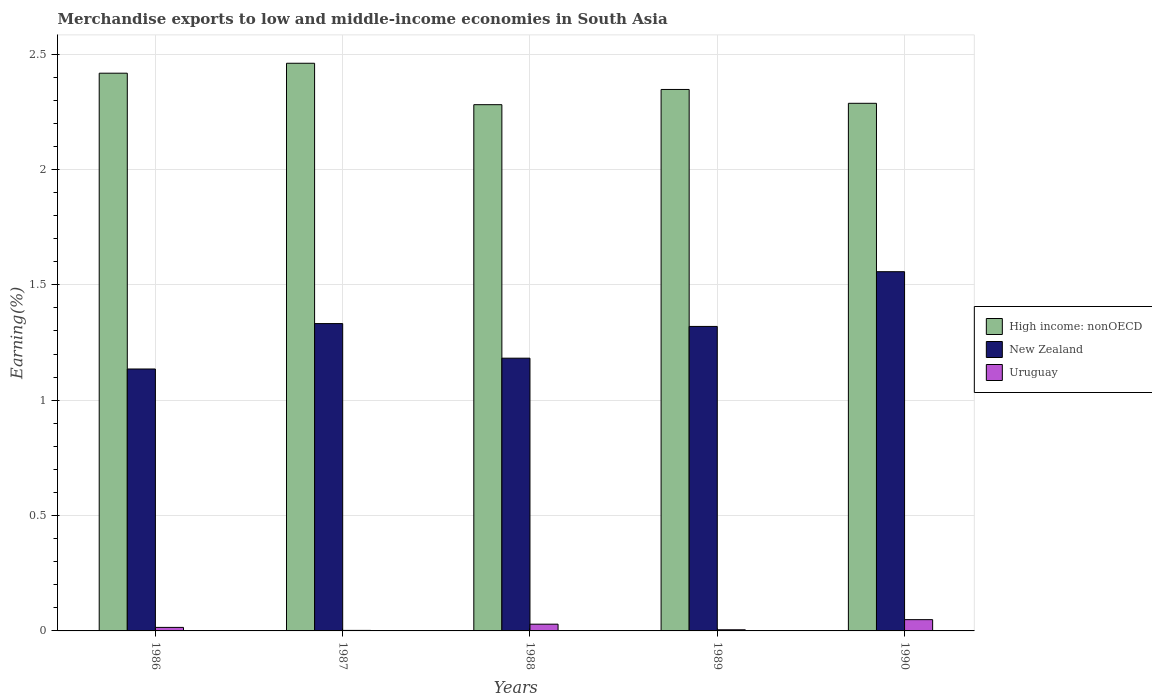How many different coloured bars are there?
Ensure brevity in your answer.  3. How many groups of bars are there?
Your answer should be compact. 5. How many bars are there on the 1st tick from the right?
Give a very brief answer. 3. In how many cases, is the number of bars for a given year not equal to the number of legend labels?
Ensure brevity in your answer.  0. What is the percentage of amount earned from merchandise exports in High income: nonOECD in 1987?
Your answer should be compact. 2.46. Across all years, what is the maximum percentage of amount earned from merchandise exports in Uruguay?
Ensure brevity in your answer.  0.05. Across all years, what is the minimum percentage of amount earned from merchandise exports in High income: nonOECD?
Provide a succinct answer. 2.28. In which year was the percentage of amount earned from merchandise exports in Uruguay maximum?
Offer a very short reply. 1990. What is the total percentage of amount earned from merchandise exports in Uruguay in the graph?
Give a very brief answer. 0.1. What is the difference between the percentage of amount earned from merchandise exports in New Zealand in 1987 and that in 1989?
Offer a very short reply. 0.01. What is the difference between the percentage of amount earned from merchandise exports in Uruguay in 1986 and the percentage of amount earned from merchandise exports in New Zealand in 1990?
Make the answer very short. -1.54. What is the average percentage of amount earned from merchandise exports in High income: nonOECD per year?
Keep it short and to the point. 2.36. In the year 1987, what is the difference between the percentage of amount earned from merchandise exports in New Zealand and percentage of amount earned from merchandise exports in High income: nonOECD?
Your response must be concise. -1.13. In how many years, is the percentage of amount earned from merchandise exports in Uruguay greater than 1.7 %?
Your answer should be compact. 0. What is the ratio of the percentage of amount earned from merchandise exports in New Zealand in 1989 to that in 1990?
Provide a succinct answer. 0.85. Is the percentage of amount earned from merchandise exports in Uruguay in 1986 less than that in 1988?
Your response must be concise. Yes. What is the difference between the highest and the second highest percentage of amount earned from merchandise exports in New Zealand?
Your answer should be compact. 0.22. What is the difference between the highest and the lowest percentage of amount earned from merchandise exports in Uruguay?
Ensure brevity in your answer.  0.05. What does the 1st bar from the left in 1987 represents?
Offer a terse response. High income: nonOECD. What does the 2nd bar from the right in 1988 represents?
Keep it short and to the point. New Zealand. Is it the case that in every year, the sum of the percentage of amount earned from merchandise exports in High income: nonOECD and percentage of amount earned from merchandise exports in New Zealand is greater than the percentage of amount earned from merchandise exports in Uruguay?
Offer a very short reply. Yes. Are all the bars in the graph horizontal?
Give a very brief answer. No. Where does the legend appear in the graph?
Provide a short and direct response. Center right. What is the title of the graph?
Your answer should be very brief. Merchandise exports to low and middle-income economies in South Asia. Does "Northern Mariana Islands" appear as one of the legend labels in the graph?
Make the answer very short. No. What is the label or title of the X-axis?
Offer a terse response. Years. What is the label or title of the Y-axis?
Offer a terse response. Earning(%). What is the Earning(%) in High income: nonOECD in 1986?
Your response must be concise. 2.42. What is the Earning(%) of New Zealand in 1986?
Ensure brevity in your answer.  1.14. What is the Earning(%) of Uruguay in 1986?
Provide a short and direct response. 0.02. What is the Earning(%) in High income: nonOECD in 1987?
Keep it short and to the point. 2.46. What is the Earning(%) in New Zealand in 1987?
Keep it short and to the point. 1.33. What is the Earning(%) in Uruguay in 1987?
Offer a very short reply. 0. What is the Earning(%) of High income: nonOECD in 1988?
Make the answer very short. 2.28. What is the Earning(%) of New Zealand in 1988?
Your answer should be compact. 1.18. What is the Earning(%) of Uruguay in 1988?
Make the answer very short. 0.03. What is the Earning(%) of High income: nonOECD in 1989?
Offer a very short reply. 2.35. What is the Earning(%) in New Zealand in 1989?
Offer a terse response. 1.32. What is the Earning(%) in Uruguay in 1989?
Keep it short and to the point. 0. What is the Earning(%) in High income: nonOECD in 1990?
Offer a terse response. 2.29. What is the Earning(%) in New Zealand in 1990?
Make the answer very short. 1.56. What is the Earning(%) in Uruguay in 1990?
Keep it short and to the point. 0.05. Across all years, what is the maximum Earning(%) in High income: nonOECD?
Your answer should be compact. 2.46. Across all years, what is the maximum Earning(%) of New Zealand?
Offer a very short reply. 1.56. Across all years, what is the maximum Earning(%) in Uruguay?
Your response must be concise. 0.05. Across all years, what is the minimum Earning(%) of High income: nonOECD?
Your response must be concise. 2.28. Across all years, what is the minimum Earning(%) of New Zealand?
Keep it short and to the point. 1.14. Across all years, what is the minimum Earning(%) of Uruguay?
Make the answer very short. 0. What is the total Earning(%) of High income: nonOECD in the graph?
Provide a succinct answer. 11.79. What is the total Earning(%) in New Zealand in the graph?
Offer a terse response. 6.53. What is the total Earning(%) of Uruguay in the graph?
Ensure brevity in your answer.  0.1. What is the difference between the Earning(%) of High income: nonOECD in 1986 and that in 1987?
Offer a terse response. -0.04. What is the difference between the Earning(%) in New Zealand in 1986 and that in 1987?
Provide a short and direct response. -0.2. What is the difference between the Earning(%) in Uruguay in 1986 and that in 1987?
Your answer should be compact. 0.01. What is the difference between the Earning(%) in High income: nonOECD in 1986 and that in 1988?
Your answer should be compact. 0.14. What is the difference between the Earning(%) of New Zealand in 1986 and that in 1988?
Offer a terse response. -0.05. What is the difference between the Earning(%) in Uruguay in 1986 and that in 1988?
Your response must be concise. -0.01. What is the difference between the Earning(%) in High income: nonOECD in 1986 and that in 1989?
Your answer should be compact. 0.07. What is the difference between the Earning(%) of New Zealand in 1986 and that in 1989?
Ensure brevity in your answer.  -0.18. What is the difference between the Earning(%) in Uruguay in 1986 and that in 1989?
Provide a succinct answer. 0.01. What is the difference between the Earning(%) of High income: nonOECD in 1986 and that in 1990?
Keep it short and to the point. 0.13. What is the difference between the Earning(%) of New Zealand in 1986 and that in 1990?
Your response must be concise. -0.42. What is the difference between the Earning(%) in Uruguay in 1986 and that in 1990?
Offer a very short reply. -0.03. What is the difference between the Earning(%) of High income: nonOECD in 1987 and that in 1988?
Your answer should be compact. 0.18. What is the difference between the Earning(%) in New Zealand in 1987 and that in 1988?
Your answer should be very brief. 0.15. What is the difference between the Earning(%) in Uruguay in 1987 and that in 1988?
Offer a very short reply. -0.03. What is the difference between the Earning(%) in High income: nonOECD in 1987 and that in 1989?
Your answer should be compact. 0.11. What is the difference between the Earning(%) in New Zealand in 1987 and that in 1989?
Make the answer very short. 0.01. What is the difference between the Earning(%) of Uruguay in 1987 and that in 1989?
Offer a very short reply. -0. What is the difference between the Earning(%) in High income: nonOECD in 1987 and that in 1990?
Ensure brevity in your answer.  0.17. What is the difference between the Earning(%) of New Zealand in 1987 and that in 1990?
Offer a very short reply. -0.22. What is the difference between the Earning(%) of Uruguay in 1987 and that in 1990?
Ensure brevity in your answer.  -0.05. What is the difference between the Earning(%) in High income: nonOECD in 1988 and that in 1989?
Offer a terse response. -0.07. What is the difference between the Earning(%) of New Zealand in 1988 and that in 1989?
Keep it short and to the point. -0.14. What is the difference between the Earning(%) in Uruguay in 1988 and that in 1989?
Your response must be concise. 0.02. What is the difference between the Earning(%) in High income: nonOECD in 1988 and that in 1990?
Ensure brevity in your answer.  -0.01. What is the difference between the Earning(%) of New Zealand in 1988 and that in 1990?
Your answer should be compact. -0.37. What is the difference between the Earning(%) in Uruguay in 1988 and that in 1990?
Your response must be concise. -0.02. What is the difference between the Earning(%) in New Zealand in 1989 and that in 1990?
Make the answer very short. -0.24. What is the difference between the Earning(%) in Uruguay in 1989 and that in 1990?
Your answer should be compact. -0.04. What is the difference between the Earning(%) of High income: nonOECD in 1986 and the Earning(%) of New Zealand in 1987?
Ensure brevity in your answer.  1.09. What is the difference between the Earning(%) of High income: nonOECD in 1986 and the Earning(%) of Uruguay in 1987?
Give a very brief answer. 2.42. What is the difference between the Earning(%) in New Zealand in 1986 and the Earning(%) in Uruguay in 1987?
Your answer should be compact. 1.13. What is the difference between the Earning(%) of High income: nonOECD in 1986 and the Earning(%) of New Zealand in 1988?
Provide a succinct answer. 1.24. What is the difference between the Earning(%) of High income: nonOECD in 1986 and the Earning(%) of Uruguay in 1988?
Ensure brevity in your answer.  2.39. What is the difference between the Earning(%) of New Zealand in 1986 and the Earning(%) of Uruguay in 1988?
Offer a very short reply. 1.11. What is the difference between the Earning(%) of High income: nonOECD in 1986 and the Earning(%) of New Zealand in 1989?
Keep it short and to the point. 1.1. What is the difference between the Earning(%) in High income: nonOECD in 1986 and the Earning(%) in Uruguay in 1989?
Offer a very short reply. 2.41. What is the difference between the Earning(%) of New Zealand in 1986 and the Earning(%) of Uruguay in 1989?
Your answer should be compact. 1.13. What is the difference between the Earning(%) of High income: nonOECD in 1986 and the Earning(%) of New Zealand in 1990?
Provide a succinct answer. 0.86. What is the difference between the Earning(%) of High income: nonOECD in 1986 and the Earning(%) of Uruguay in 1990?
Your answer should be very brief. 2.37. What is the difference between the Earning(%) in New Zealand in 1986 and the Earning(%) in Uruguay in 1990?
Ensure brevity in your answer.  1.09. What is the difference between the Earning(%) in High income: nonOECD in 1987 and the Earning(%) in New Zealand in 1988?
Provide a succinct answer. 1.28. What is the difference between the Earning(%) in High income: nonOECD in 1987 and the Earning(%) in Uruguay in 1988?
Your answer should be very brief. 2.43. What is the difference between the Earning(%) of New Zealand in 1987 and the Earning(%) of Uruguay in 1988?
Provide a succinct answer. 1.3. What is the difference between the Earning(%) in High income: nonOECD in 1987 and the Earning(%) in New Zealand in 1989?
Provide a succinct answer. 1.14. What is the difference between the Earning(%) in High income: nonOECD in 1987 and the Earning(%) in Uruguay in 1989?
Provide a succinct answer. 2.46. What is the difference between the Earning(%) of New Zealand in 1987 and the Earning(%) of Uruguay in 1989?
Keep it short and to the point. 1.33. What is the difference between the Earning(%) of High income: nonOECD in 1987 and the Earning(%) of New Zealand in 1990?
Your answer should be compact. 0.9. What is the difference between the Earning(%) in High income: nonOECD in 1987 and the Earning(%) in Uruguay in 1990?
Your answer should be compact. 2.41. What is the difference between the Earning(%) in New Zealand in 1987 and the Earning(%) in Uruguay in 1990?
Provide a succinct answer. 1.28. What is the difference between the Earning(%) of High income: nonOECD in 1988 and the Earning(%) of New Zealand in 1989?
Provide a short and direct response. 0.96. What is the difference between the Earning(%) in High income: nonOECD in 1988 and the Earning(%) in Uruguay in 1989?
Provide a succinct answer. 2.28. What is the difference between the Earning(%) of New Zealand in 1988 and the Earning(%) of Uruguay in 1989?
Make the answer very short. 1.18. What is the difference between the Earning(%) in High income: nonOECD in 1988 and the Earning(%) in New Zealand in 1990?
Offer a very short reply. 0.72. What is the difference between the Earning(%) in High income: nonOECD in 1988 and the Earning(%) in Uruguay in 1990?
Ensure brevity in your answer.  2.23. What is the difference between the Earning(%) in New Zealand in 1988 and the Earning(%) in Uruguay in 1990?
Make the answer very short. 1.13. What is the difference between the Earning(%) in High income: nonOECD in 1989 and the Earning(%) in New Zealand in 1990?
Provide a short and direct response. 0.79. What is the difference between the Earning(%) of High income: nonOECD in 1989 and the Earning(%) of Uruguay in 1990?
Make the answer very short. 2.3. What is the difference between the Earning(%) of New Zealand in 1989 and the Earning(%) of Uruguay in 1990?
Make the answer very short. 1.27. What is the average Earning(%) in High income: nonOECD per year?
Keep it short and to the point. 2.36. What is the average Earning(%) of New Zealand per year?
Your response must be concise. 1.31. What is the average Earning(%) in Uruguay per year?
Your answer should be very brief. 0.02. In the year 1986, what is the difference between the Earning(%) in High income: nonOECD and Earning(%) in New Zealand?
Your answer should be compact. 1.28. In the year 1986, what is the difference between the Earning(%) of High income: nonOECD and Earning(%) of Uruguay?
Keep it short and to the point. 2.4. In the year 1986, what is the difference between the Earning(%) in New Zealand and Earning(%) in Uruguay?
Give a very brief answer. 1.12. In the year 1987, what is the difference between the Earning(%) in High income: nonOECD and Earning(%) in New Zealand?
Your response must be concise. 1.13. In the year 1987, what is the difference between the Earning(%) of High income: nonOECD and Earning(%) of Uruguay?
Ensure brevity in your answer.  2.46. In the year 1987, what is the difference between the Earning(%) of New Zealand and Earning(%) of Uruguay?
Your response must be concise. 1.33. In the year 1988, what is the difference between the Earning(%) of High income: nonOECD and Earning(%) of New Zealand?
Your answer should be very brief. 1.1. In the year 1988, what is the difference between the Earning(%) in High income: nonOECD and Earning(%) in Uruguay?
Provide a succinct answer. 2.25. In the year 1988, what is the difference between the Earning(%) in New Zealand and Earning(%) in Uruguay?
Keep it short and to the point. 1.15. In the year 1989, what is the difference between the Earning(%) in High income: nonOECD and Earning(%) in New Zealand?
Keep it short and to the point. 1.03. In the year 1989, what is the difference between the Earning(%) in High income: nonOECD and Earning(%) in Uruguay?
Make the answer very short. 2.34. In the year 1989, what is the difference between the Earning(%) in New Zealand and Earning(%) in Uruguay?
Your answer should be very brief. 1.31. In the year 1990, what is the difference between the Earning(%) of High income: nonOECD and Earning(%) of New Zealand?
Give a very brief answer. 0.73. In the year 1990, what is the difference between the Earning(%) in High income: nonOECD and Earning(%) in Uruguay?
Your response must be concise. 2.24. In the year 1990, what is the difference between the Earning(%) of New Zealand and Earning(%) of Uruguay?
Give a very brief answer. 1.51. What is the ratio of the Earning(%) of High income: nonOECD in 1986 to that in 1987?
Give a very brief answer. 0.98. What is the ratio of the Earning(%) in New Zealand in 1986 to that in 1987?
Keep it short and to the point. 0.85. What is the ratio of the Earning(%) in Uruguay in 1986 to that in 1987?
Offer a very short reply. 6.72. What is the ratio of the Earning(%) in High income: nonOECD in 1986 to that in 1988?
Ensure brevity in your answer.  1.06. What is the ratio of the Earning(%) of New Zealand in 1986 to that in 1988?
Provide a succinct answer. 0.96. What is the ratio of the Earning(%) in Uruguay in 1986 to that in 1988?
Provide a short and direct response. 0.52. What is the ratio of the Earning(%) of High income: nonOECD in 1986 to that in 1989?
Give a very brief answer. 1.03. What is the ratio of the Earning(%) in New Zealand in 1986 to that in 1989?
Your answer should be compact. 0.86. What is the ratio of the Earning(%) of Uruguay in 1986 to that in 1989?
Give a very brief answer. 3.08. What is the ratio of the Earning(%) of High income: nonOECD in 1986 to that in 1990?
Make the answer very short. 1.06. What is the ratio of the Earning(%) in New Zealand in 1986 to that in 1990?
Give a very brief answer. 0.73. What is the ratio of the Earning(%) of Uruguay in 1986 to that in 1990?
Offer a very short reply. 0.31. What is the ratio of the Earning(%) in High income: nonOECD in 1987 to that in 1988?
Give a very brief answer. 1.08. What is the ratio of the Earning(%) in New Zealand in 1987 to that in 1988?
Provide a short and direct response. 1.13. What is the ratio of the Earning(%) of Uruguay in 1987 to that in 1988?
Make the answer very short. 0.08. What is the ratio of the Earning(%) of High income: nonOECD in 1987 to that in 1989?
Your answer should be very brief. 1.05. What is the ratio of the Earning(%) in New Zealand in 1987 to that in 1989?
Make the answer very short. 1.01. What is the ratio of the Earning(%) of Uruguay in 1987 to that in 1989?
Your response must be concise. 0.46. What is the ratio of the Earning(%) of High income: nonOECD in 1987 to that in 1990?
Offer a terse response. 1.08. What is the ratio of the Earning(%) of New Zealand in 1987 to that in 1990?
Ensure brevity in your answer.  0.86. What is the ratio of the Earning(%) of Uruguay in 1987 to that in 1990?
Make the answer very short. 0.05. What is the ratio of the Earning(%) of High income: nonOECD in 1988 to that in 1989?
Your answer should be very brief. 0.97. What is the ratio of the Earning(%) of New Zealand in 1988 to that in 1989?
Give a very brief answer. 0.9. What is the ratio of the Earning(%) in Uruguay in 1988 to that in 1989?
Ensure brevity in your answer.  5.9. What is the ratio of the Earning(%) of High income: nonOECD in 1988 to that in 1990?
Make the answer very short. 1. What is the ratio of the Earning(%) of New Zealand in 1988 to that in 1990?
Give a very brief answer. 0.76. What is the ratio of the Earning(%) in Uruguay in 1988 to that in 1990?
Keep it short and to the point. 0.6. What is the ratio of the Earning(%) of High income: nonOECD in 1989 to that in 1990?
Provide a short and direct response. 1.03. What is the ratio of the Earning(%) in New Zealand in 1989 to that in 1990?
Ensure brevity in your answer.  0.85. What is the ratio of the Earning(%) in Uruguay in 1989 to that in 1990?
Make the answer very short. 0.1. What is the difference between the highest and the second highest Earning(%) in High income: nonOECD?
Your answer should be very brief. 0.04. What is the difference between the highest and the second highest Earning(%) of New Zealand?
Your answer should be compact. 0.22. What is the difference between the highest and the second highest Earning(%) of Uruguay?
Your answer should be very brief. 0.02. What is the difference between the highest and the lowest Earning(%) in High income: nonOECD?
Your answer should be very brief. 0.18. What is the difference between the highest and the lowest Earning(%) in New Zealand?
Your answer should be very brief. 0.42. What is the difference between the highest and the lowest Earning(%) in Uruguay?
Offer a very short reply. 0.05. 